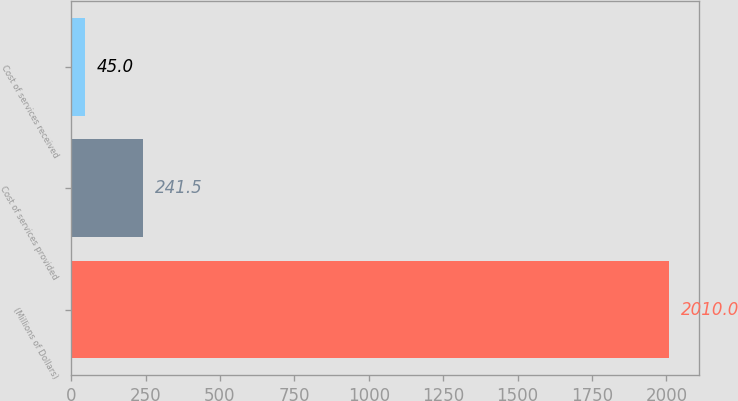<chart> <loc_0><loc_0><loc_500><loc_500><bar_chart><fcel>(Millions of Dollars)<fcel>Cost of services provided<fcel>Cost of services received<nl><fcel>2010<fcel>241.5<fcel>45<nl></chart> 